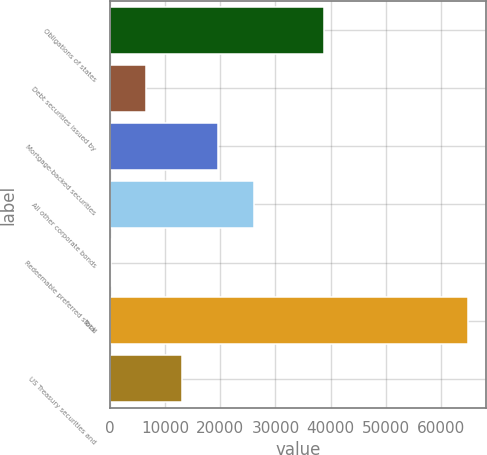<chart> <loc_0><loc_0><loc_500><loc_500><bar_chart><fcel>Obligations of states<fcel>Debt securities issued by<fcel>Mortgage-backed securities<fcel>All other corporate bonds<fcel>Redeemable preferred stock<fcel>Total<fcel>US Treasury securities and<nl><fcel>38822<fcel>6583.8<fcel>19547.4<fcel>26029.2<fcel>102<fcel>64920<fcel>13065.6<nl></chart> 